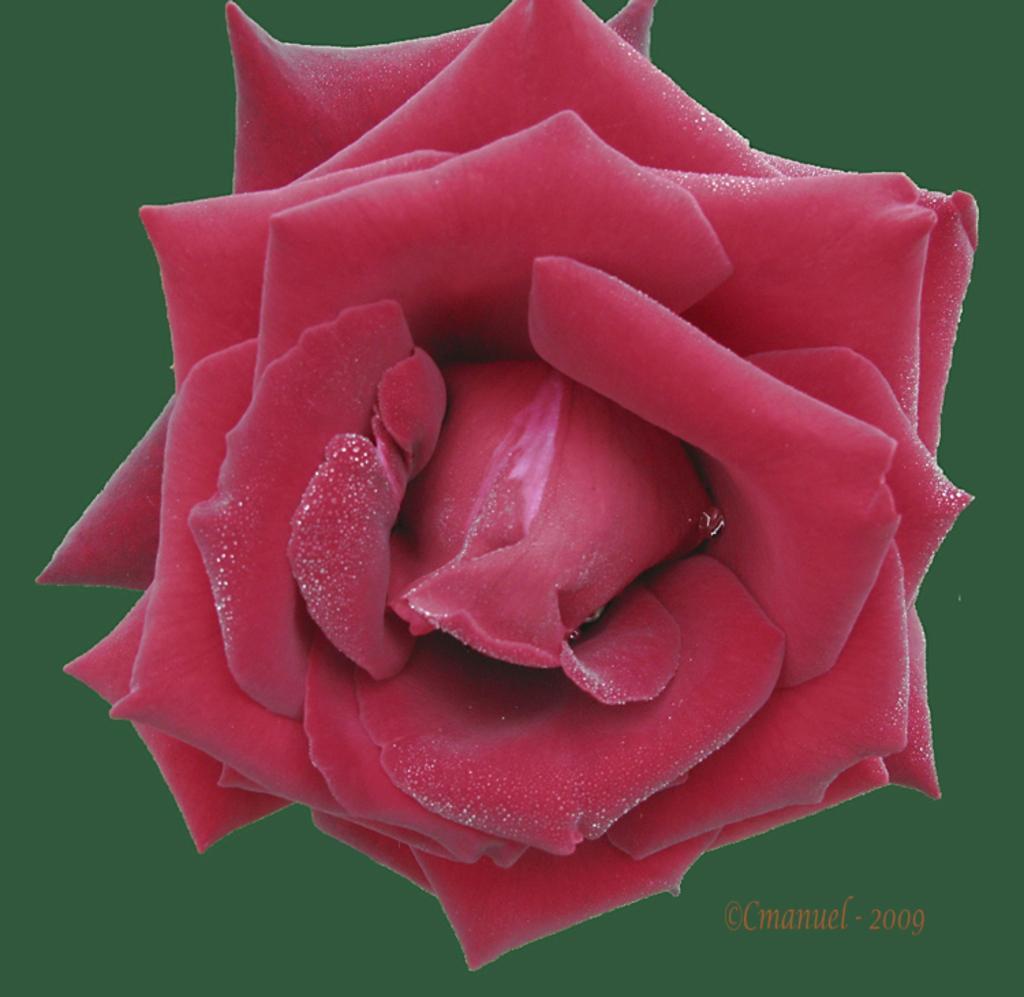In one or two sentences, can you explain what this image depicts? It's a beautiful red rose, there is a water marker in the down side of an image. 